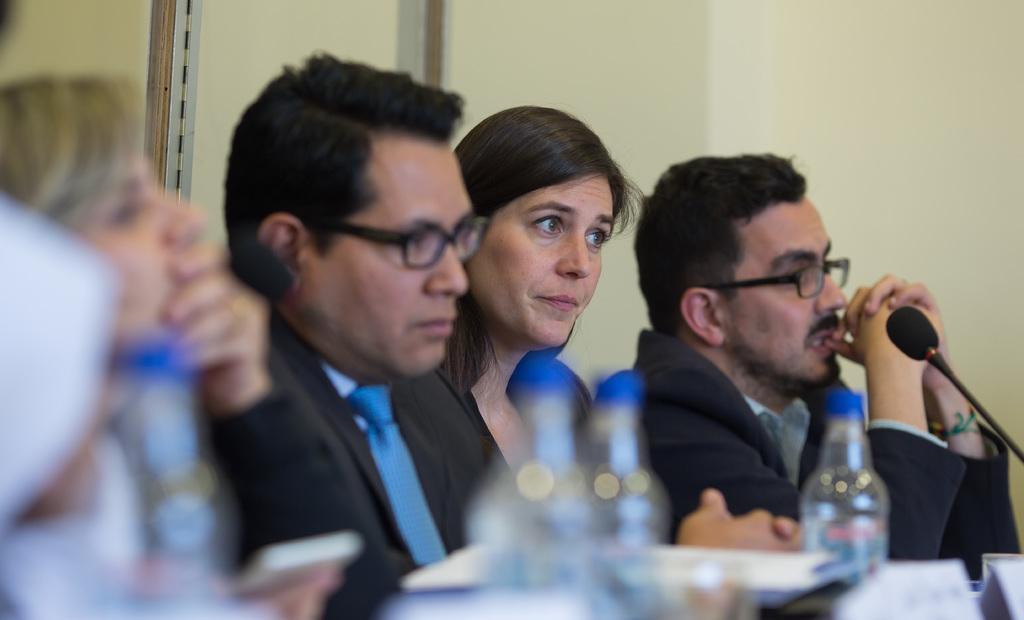In one or two sentences, can you explain what this image depicts? In this image we can see a few people sitting and in front of them there are objects like water bottles, microphone and some other things. 